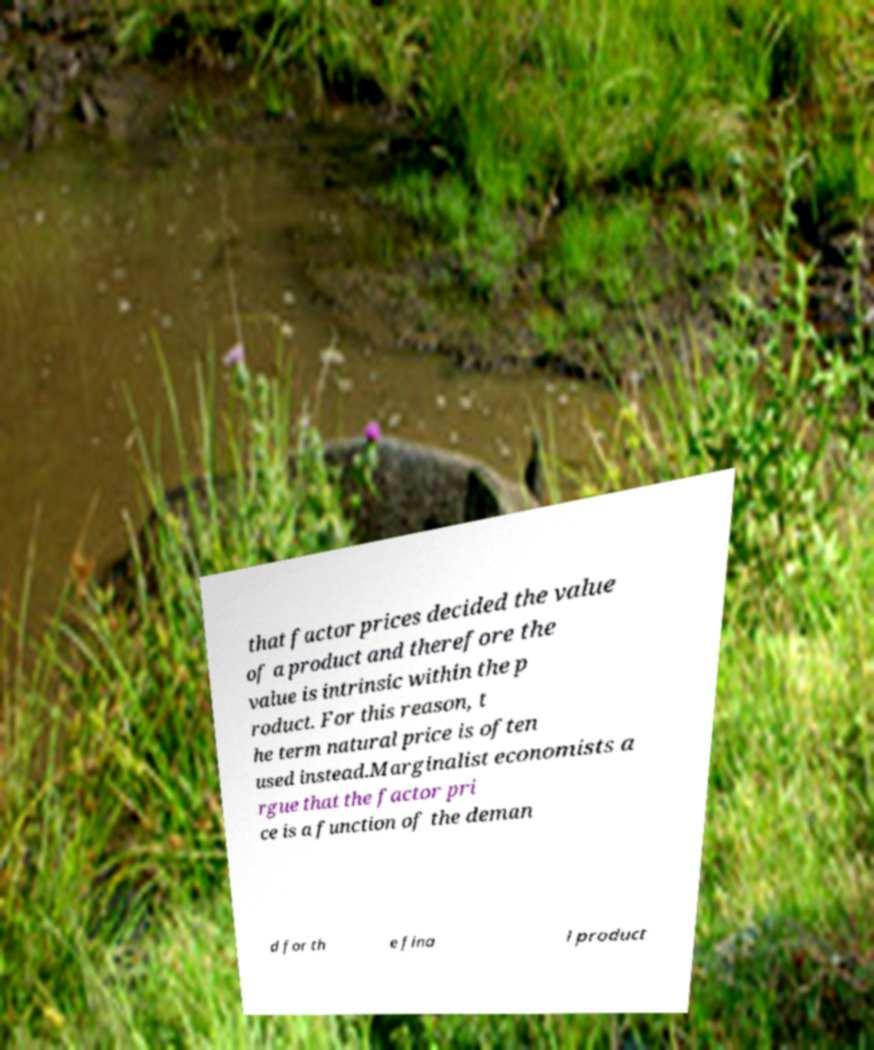Please read and relay the text visible in this image. What does it say? that factor prices decided the value of a product and therefore the value is intrinsic within the p roduct. For this reason, t he term natural price is often used instead.Marginalist economists a rgue that the factor pri ce is a function of the deman d for th e fina l product 